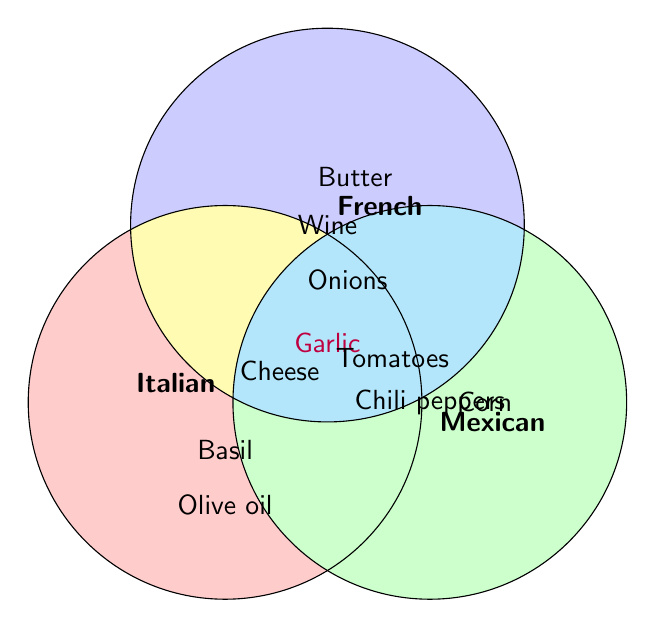What ingredient is shared among all three cuisines? The overlapping section within all three circles contains the ingredient "Garlic." Therefore, "Garlic" is shared among the Italian, French, and Mexican cuisines.
Answer: Garlic Which ingredients are unique to the Italian cuisine? Unique ingredients to the Italian cuisine are those found only in the Italian circle and not overlapping with any other circles. These ingredients are: Olive oil and Basil.
Answer: Olive oil, Basil What ingredients are shared between Italian and French cuisines? The shared ingredients between Italian and French cuisines are located in the intersecting area of the Italian and French circles but not in the Mexican circle. These ingredients are: Garlic and Cheese.
Answer: Garlic, Cheese How many ingredients are unique to the Mexican cuisine? Unique ingredients to the Mexican cuisine are those found only in the Mexican circle and not overlapping with any other circles. These ingredients are: Corn and Chili peppers. There are 2 such ingredients.
Answer: 2 Is "Tomatoes" an ingredient shared among all three cuisines? "Tomatoes" is not in the overlapping section of all three circles. It is found in the overlapping sections between Italian and Mexican cuisines but not in the French cuisine.
Answer: No Which two cuisines share the ingredient "Onions"? The ingredient "Onions" is in the overlapping section between French and Mexican circles. Therefore, French and Mexican cuisines share "Onions."
Answer: French and Mexican How many ingredients are shared between the most cuisine pairs? The ingredient that appears in the most intersections is "Garlic," which appears in all three circles, i.e., shared among all three cuisines.
Answer: 1 Which cuisine has the most unique ingredients not shared with the others? Italian cuisine has the most unique ingredients not shared with the others, as it has "Olive oil" and "Basil" (total 2), while French has Butter and Wine, and Mexican has Corn and Chili peppers (2 each as well).
Answer: Italian What is the combined total number of ingredients shared between Italian & French and French & Mexican? The ingredients shared between Italian & French are Garlic and Cheese (2), and French & Mexican are Garlic and Onions (2). Summing these we get 2 + 2 = 4. Note: Garlic is counted once in each shared subset.
Answer: 4 Which ingredient is shared between the Italian and Mexican cuisines but not French? The ingredient "Tomatoes" is shared between the Italian and Mexican cuisines but not found in the French circle.
Answer: Tomatoes 